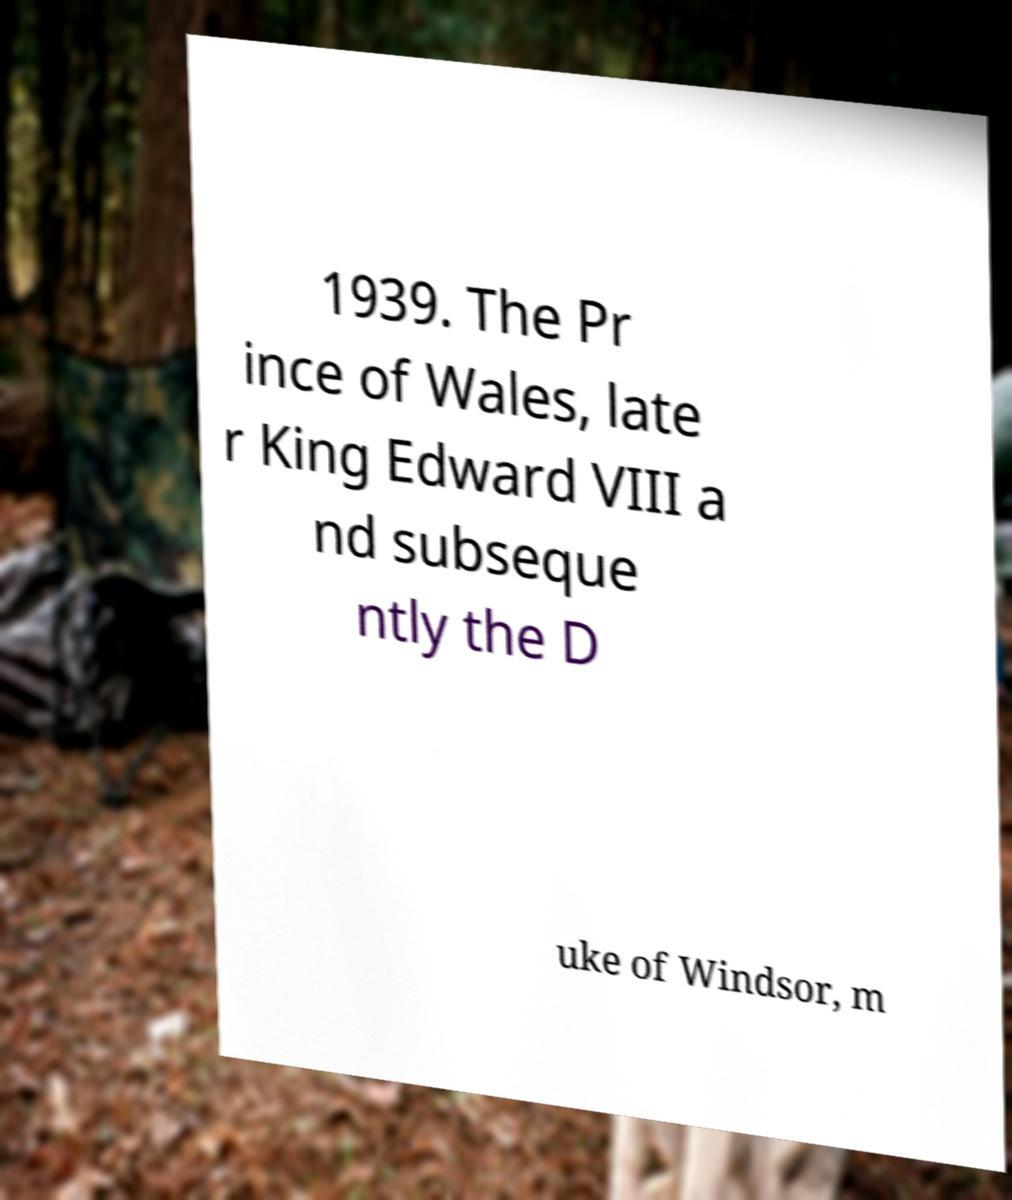What messages or text are displayed in this image? I need them in a readable, typed format. 1939. The Pr ince of Wales, late r King Edward VIII a nd subseque ntly the D uke of Windsor, m 